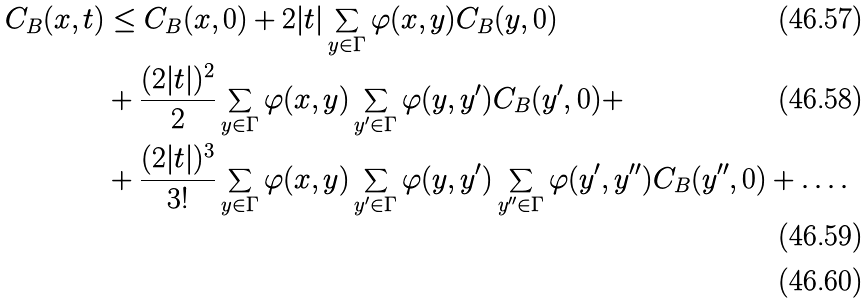Convert formula to latex. <formula><loc_0><loc_0><loc_500><loc_500>C _ { B } ( x , t ) & \leq C _ { B } ( x , 0 ) + 2 | t | \sum _ { y \in \Gamma } \varphi ( x , y ) C _ { B } ( y , 0 ) \\ & + \frac { ( 2 | t | ) ^ { 2 } } { 2 } \sum _ { y \in \Gamma } \varphi ( x , y ) \sum _ { y ^ { \prime } \in \Gamma } \varphi ( y , y ^ { \prime } ) C _ { B } ( y ^ { \prime } , 0 ) + \\ & + \frac { ( 2 | t | ) ^ { 3 } } { 3 ! } \sum _ { y \in \Gamma } \varphi ( x , y ) \sum _ { y ^ { \prime } \in \Gamma } \varphi ( y , y ^ { \prime } ) \sum _ { y ^ { \prime \prime } \in \Gamma } \varphi ( y ^ { \prime } , y ^ { \prime \prime } ) C _ { B } ( y ^ { \prime \prime } , 0 ) + \dots . \\</formula> 